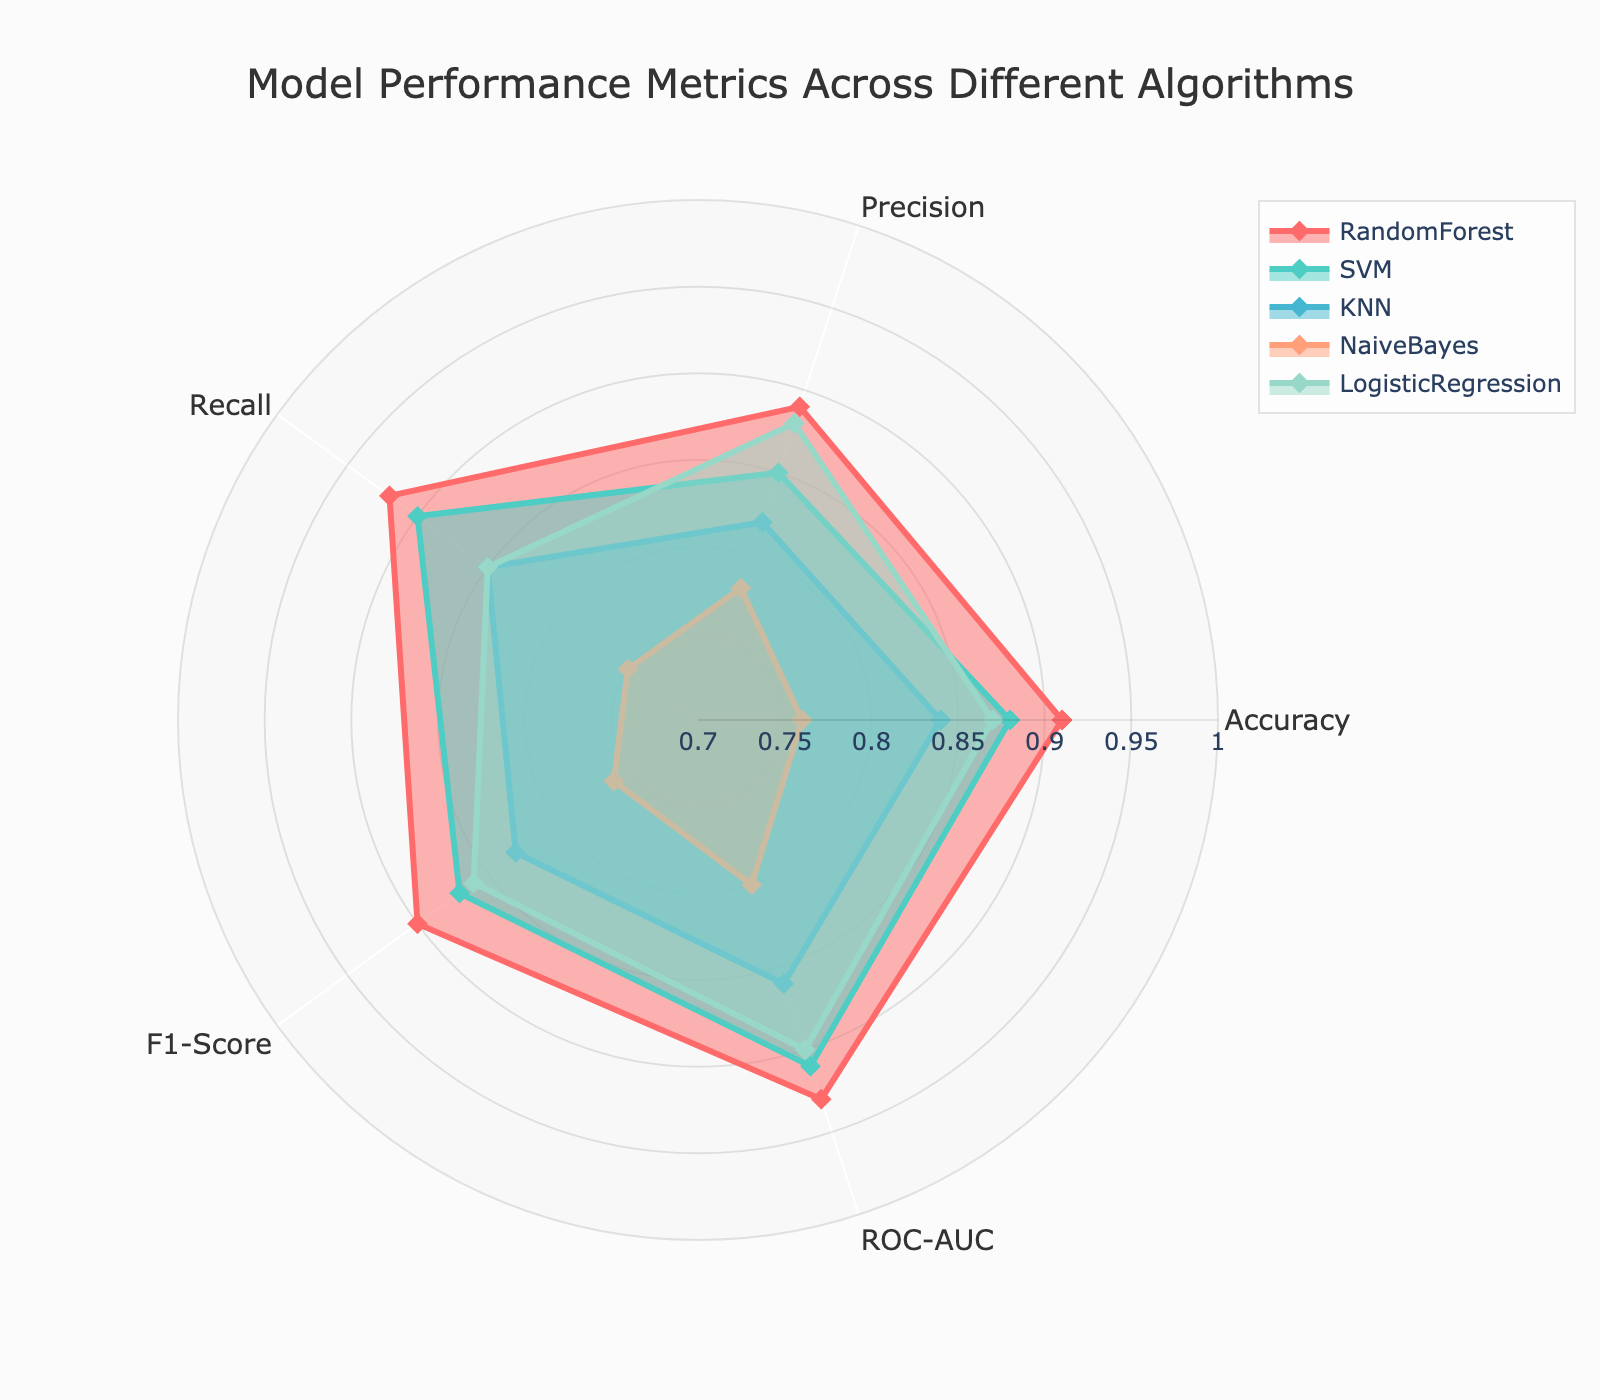What is the title of the figure? The title of the figure is displayed at the top, which reads 'Model Performance Metrics Across Different Algorithms'.
Answer: Model Performance Metrics Across Different Algorithms How many different algorithms are represented in the radar chart? The radar chart features five distinct algorithms, identified by their colors and names in the legend.
Answer: 5 Which algorithm has the highest accuracy? By looking at the 'Accuracy' value on the radar chart, the RandomForest algorithm has the highest accuracy of all the algorithms.
Answer: RandomForest Is the Precision of SVM higher than the Precision of KNN? Comparing the 'Precision' values on the radar chart, the Precision of SVM (0.85) is indeed higher than that of KNN (0.82).
Answer: Yes Which algorithm has the highest ROC-AUC? The ROC-AUC values can be observed on the radar chart, where the RandomForest algorithm has the highest ROC-AUC of 0.93.
Answer: RandomForest Does the NaiveBayes algorithm have any metric higher than 0.80? By examining the metrics for NaiveBayes on the radar chart, all values are below or equal to 0.80, with no metric surpassing 0.80.
Answer: No What's the average Recall value for SVM and LogisticRegression? The Recall values for SVM and LogisticRegression are 0.90 and 0.85, respectively. The average is calculated as (0.90 + 0.85) / 2 = 0.875.
Answer: 0.875 Compare the F1-Score of RandomForest and NaiveBayes. Which one is higher and by how much? The F1-Score of RandomForest is 0.90, while NaiveBayes has an F1-Score of 0.76. The difference is 0.90 - 0.76 = 0.14, making RandomForest's F1-Score higher by 0.14.
Answer: RandomForest by 0.14 Among RandomForest, SVM, and KNN, which algorithm has the lowest Recall? Evaluating the Recall metrics, KNN has the lowest Recall value of the three algorithms, with a value of 0.85.
Answer: KNN Which algorithm's shape on the radar chart covers the largest area, and what does it signify? The RandomForest algorithm's shape spans the largest area on the radar chart. This widespread coverage indicates that RandomForest generally has the best performance across multiple metrics.
Answer: RandomForest, best performance 